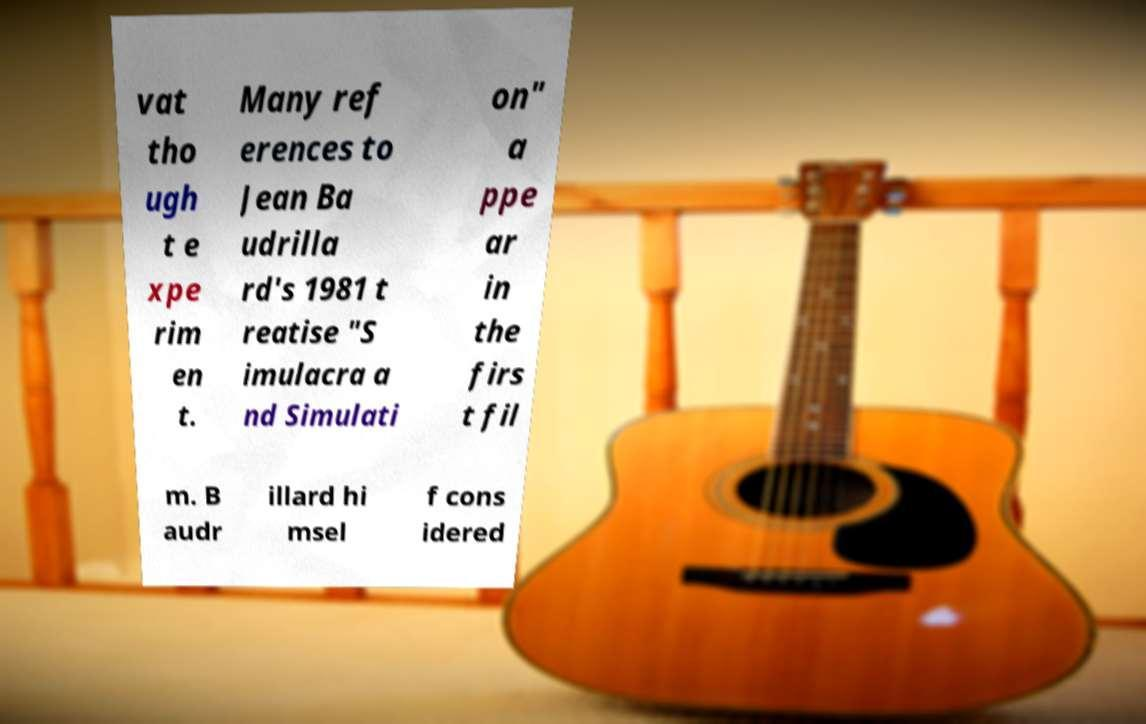There's text embedded in this image that I need extracted. Can you transcribe it verbatim? vat tho ugh t e xpe rim en t. Many ref erences to Jean Ba udrilla rd's 1981 t reatise "S imulacra a nd Simulati on" a ppe ar in the firs t fil m. B audr illard hi msel f cons idered 